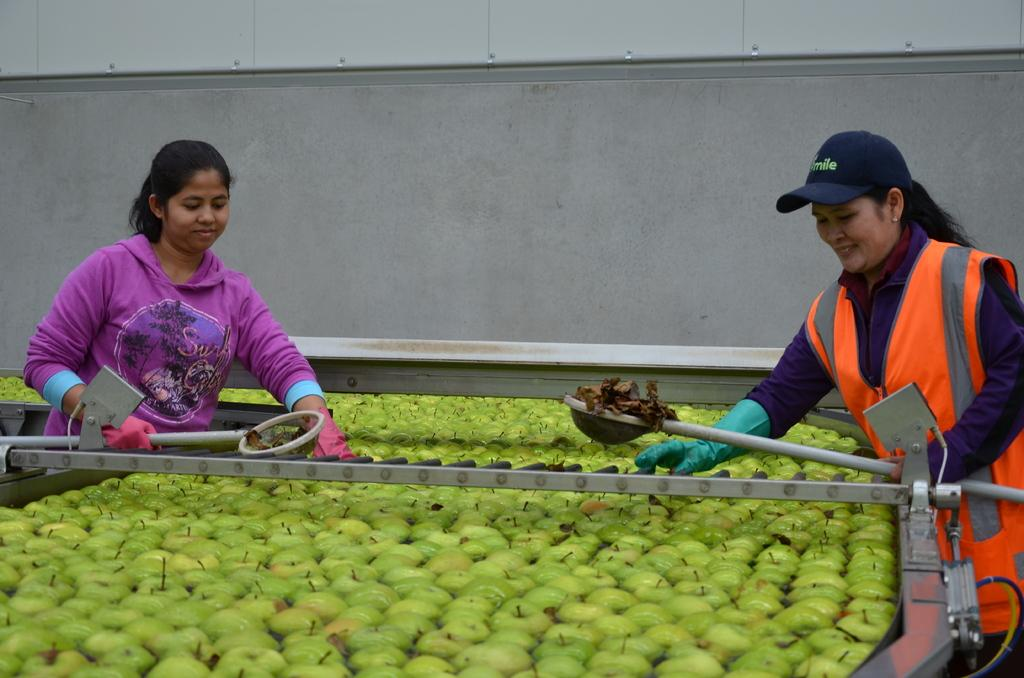What is the main structure in the image? There is a big wall in the image. Who is present in the image? There are two women standing in the image. What are the women holding in the image? The women are holding objects. What can be seen on the surface in the image? There are fruits and other objects on the surface in the image. What else can be seen in the image? There are wires and a machine visible in the image. What type of punishment is being administered to the women in the image? There is no indication of punishment in the image; the women are simply standing and holding objects. What type of building is depicted in the image? The image does not show a building; it features a big wall and other objects. 